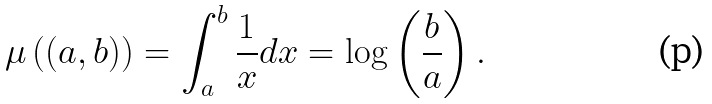Convert formula to latex. <formula><loc_0><loc_0><loc_500><loc_500>\mu \left ( ( a , b ) \right ) = \int _ { a } ^ { b } \frac { 1 } { x } d x = \log \left ( \frac { b } { a } \right ) .</formula> 